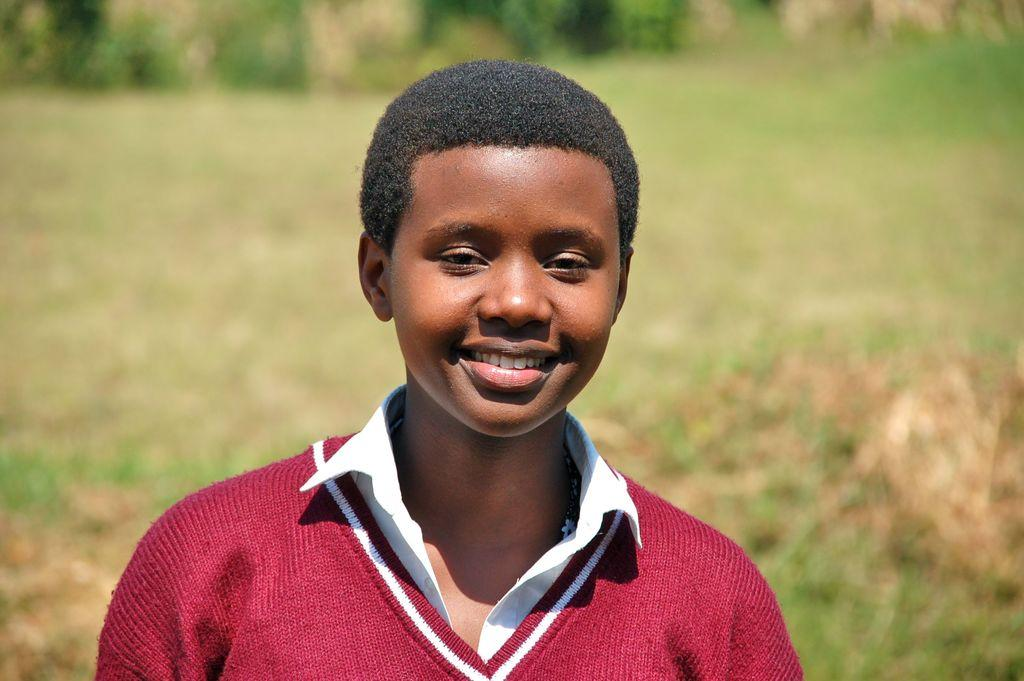Who or what is the main subject in the image? There is a person in the image. Can you describe the person's attire? The person is wearing a white and maroon color dress. What is the person's facial expression? The person is smiling. What can be seen in the background of the image? There are trees in the background of the image. How would you describe the background'background's appearance? The background is blurry. How many chairs are visible in the image? There are no chairs visible in the image. What type of tooth is the person showing in the image? The person is not showing any tooth in the image. 